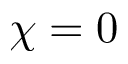Convert formula to latex. <formula><loc_0><loc_0><loc_500><loc_500>{ \chi = 0 }</formula> 